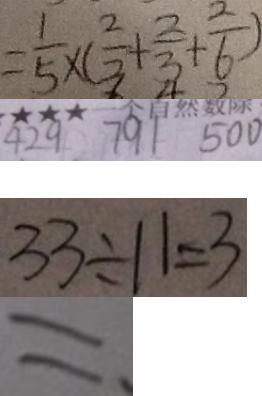Convert formula to latex. <formula><loc_0><loc_0><loc_500><loc_500>= \frac { 1 } { 5 } \times ( \frac { 2 } { 3 } + \frac { 2 } { 3 } + \frac { 2 } { 6 } ) 
 4 2 9 7 9 1 5 0 0 
 3 3 \div 1 1 = 3 
 =</formula> 